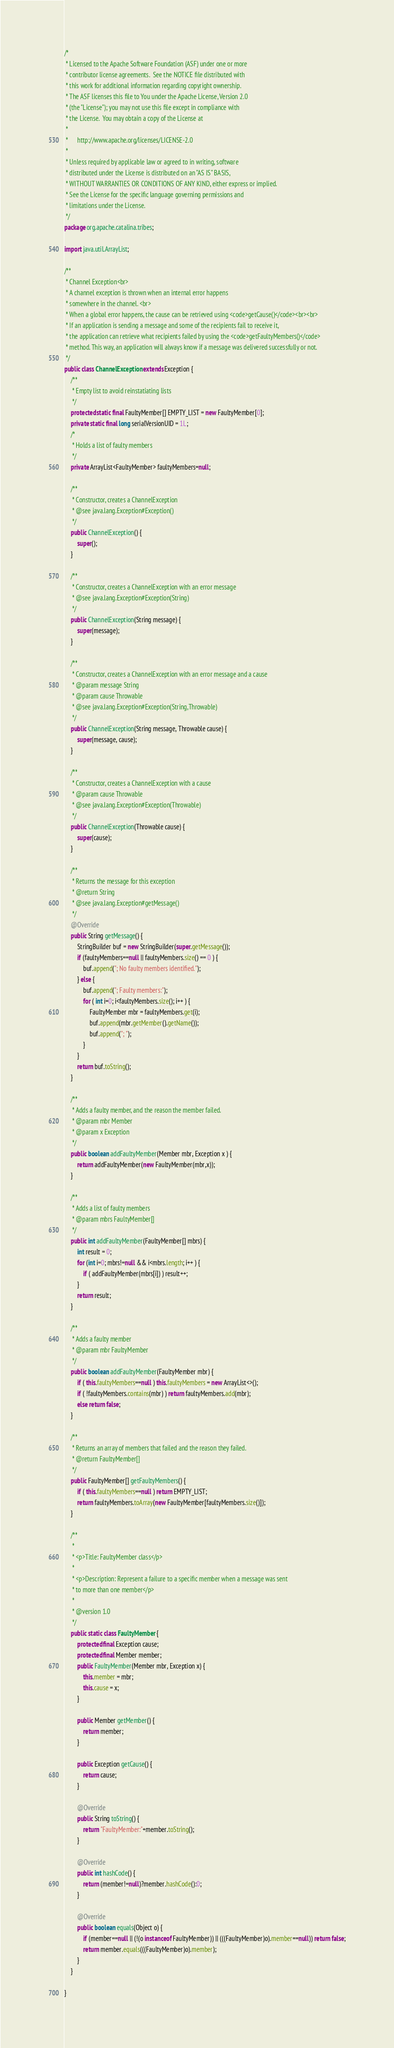<code> <loc_0><loc_0><loc_500><loc_500><_Java_>/*
 * Licensed to the Apache Software Foundation (ASF) under one or more
 * contributor license agreements.  See the NOTICE file distributed with
 * this work for additional information regarding copyright ownership.
 * The ASF licenses this file to You under the Apache License, Version 2.0
 * (the "License"); you may not use this file except in compliance with
 * the License.  You may obtain a copy of the License at
 *
 *      http://www.apache.org/licenses/LICENSE-2.0
 *
 * Unless required by applicable law or agreed to in writing, software
 * distributed under the License is distributed on an "AS IS" BASIS,
 * WITHOUT WARRANTIES OR CONDITIONS OF ANY KIND, either express or implied.
 * See the License for the specific language governing permissions and
 * limitations under the License.
 */
package org.apache.catalina.tribes;

import java.util.ArrayList;

/**
 * Channel Exception<br>
 * A channel exception is thrown when an internal error happens
 * somewhere in the channel. <br>
 * When a global error happens, the cause can be retrieved using <code>getCause()</code><br><br>
 * If an application is sending a message and some of the recipients fail to receive it,
 * the application can retrieve what recipients failed by using the <code>getFaultyMembers()</code>
 * method. This way, an application will always know if a message was delivered successfully or not.
 */
public class ChannelException extends Exception {
    /**
     * Empty list to avoid reinstatiating lists
     */
    protected static final FaultyMember[] EMPTY_LIST = new FaultyMember[0];
    private static final long serialVersionUID = 1L;
    /*
     * Holds a list of faulty members
     */
    private ArrayList<FaultyMember> faultyMembers=null;

    /**
     * Constructor, creates a ChannelException
     * @see java.lang.Exception#Exception()
     */
    public ChannelException() {
        super();
    }

    /**
     * Constructor, creates a ChannelException with an error message
     * @see java.lang.Exception#Exception(String)
     */
    public ChannelException(String message) {
        super(message);
    }

    /**
     * Constructor, creates a ChannelException with an error message and a cause
     * @param message String
     * @param cause Throwable
     * @see java.lang.Exception#Exception(String,Throwable)
     */
    public ChannelException(String message, Throwable cause) {
        super(message, cause);
    }

    /**
     * Constructor, creates a ChannelException with a cause
     * @param cause Throwable
     * @see java.lang.Exception#Exception(Throwable)
     */
    public ChannelException(Throwable cause) {
        super(cause);
    }

    /**
     * Returns the message for this exception
     * @return String
     * @see java.lang.Exception#getMessage()
     */
    @Override
    public String getMessage() {
        StringBuilder buf = new StringBuilder(super.getMessage());
        if (faultyMembers==null || faultyMembers.size() == 0 ) {
            buf.append("; No faulty members identified.");
        } else {
            buf.append("; Faulty members:");
            for ( int i=0; i<faultyMembers.size(); i++ ) {
                FaultyMember mbr = faultyMembers.get(i);
                buf.append(mbr.getMember().getName());
                buf.append("; ");
            }
        }
        return buf.toString();
    }

    /**
     * Adds a faulty member, and the reason the member failed.
     * @param mbr Member
     * @param x Exception
     */
    public boolean addFaultyMember(Member mbr, Exception x ) {
        return addFaultyMember(new FaultyMember(mbr,x));
    }

    /**
     * Adds a list of faulty members
     * @param mbrs FaultyMember[]
     */
    public int addFaultyMember(FaultyMember[] mbrs) {
        int result = 0;
        for (int i=0; mbrs!=null && i<mbrs.length; i++ ) {
            if ( addFaultyMember(mbrs[i]) ) result++;
        }
        return result;
    }

    /**
     * Adds a faulty member
     * @param mbr FaultyMember
     */
    public boolean addFaultyMember(FaultyMember mbr) {
        if ( this.faultyMembers==null ) this.faultyMembers = new ArrayList<>();
        if ( !faultyMembers.contains(mbr) ) return faultyMembers.add(mbr);
        else return false;
    }

    /**
     * Returns an array of members that failed and the reason they failed.
     * @return FaultyMember[]
     */
    public FaultyMember[] getFaultyMembers() {
        if ( this.faultyMembers==null ) return EMPTY_LIST;
        return faultyMembers.toArray(new FaultyMember[faultyMembers.size()]);
    }

    /**
     *
     * <p>Title: FaultyMember class</p>
     *
     * <p>Description: Represent a failure to a specific member when a message was sent
     * to more than one member</p>
     *
     * @version 1.0
     */
    public static class FaultyMember {
        protected final Exception cause;
        protected final Member member;
        public FaultyMember(Member mbr, Exception x) {
            this.member = mbr;
            this.cause = x;
        }

        public Member getMember() {
            return member;
        }

        public Exception getCause() {
            return cause;
        }

        @Override
        public String toString() {
            return "FaultyMember:"+member.toString();
        }

        @Override
        public int hashCode() {
            return (member!=null)?member.hashCode():0;
        }

        @Override
        public boolean equals(Object o) {
            if (member==null || (!(o instanceof FaultyMember)) || (((FaultyMember)o).member==null)) return false;
            return member.equals(((FaultyMember)o).member);
        }
    }

}
</code> 